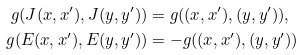Convert formula to latex. <formula><loc_0><loc_0><loc_500><loc_500>g ( J ( x , x ^ { \prime } ) , J ( y , y ^ { \prime } ) ) & = g ( ( x , x ^ { \prime } ) , ( y , y ^ { \prime } ) ) , \\ g ( E ( x , x ^ { \prime } ) , E ( y , y ^ { \prime } ) ) & = - g ( ( x , x ^ { \prime } ) , ( y , y ^ { \prime } ) )</formula> 